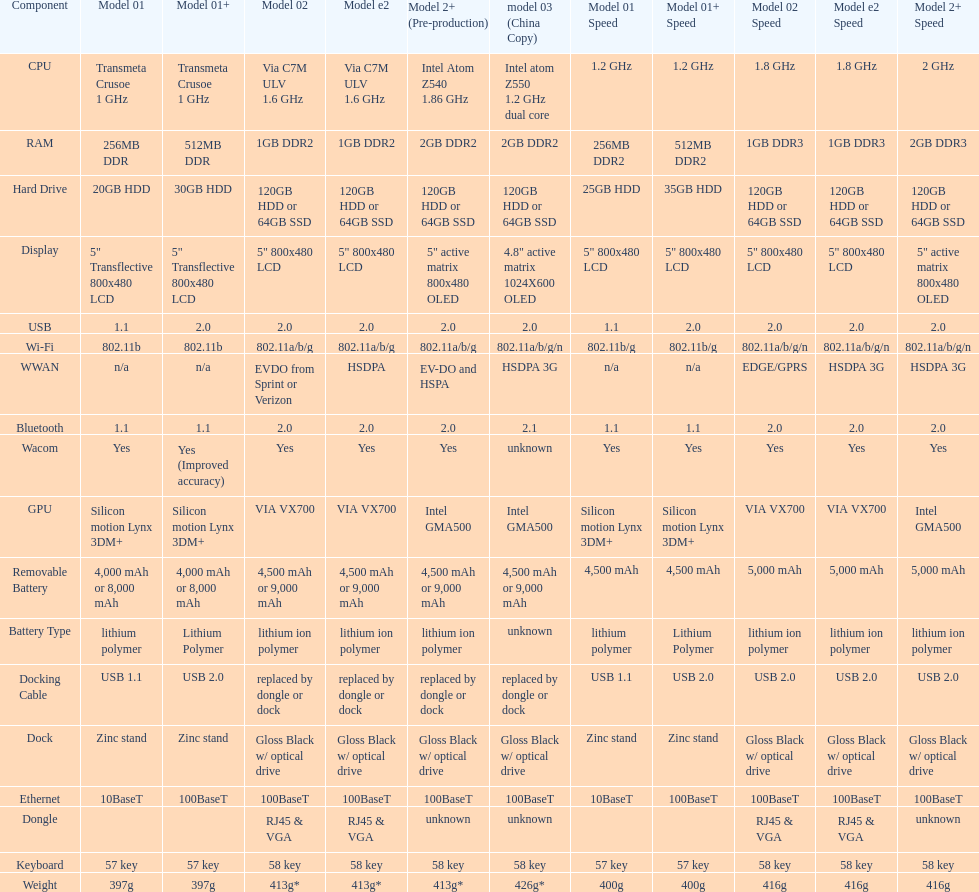Which model provides a larger hard drive: model 01 or model 02? Model 02. 